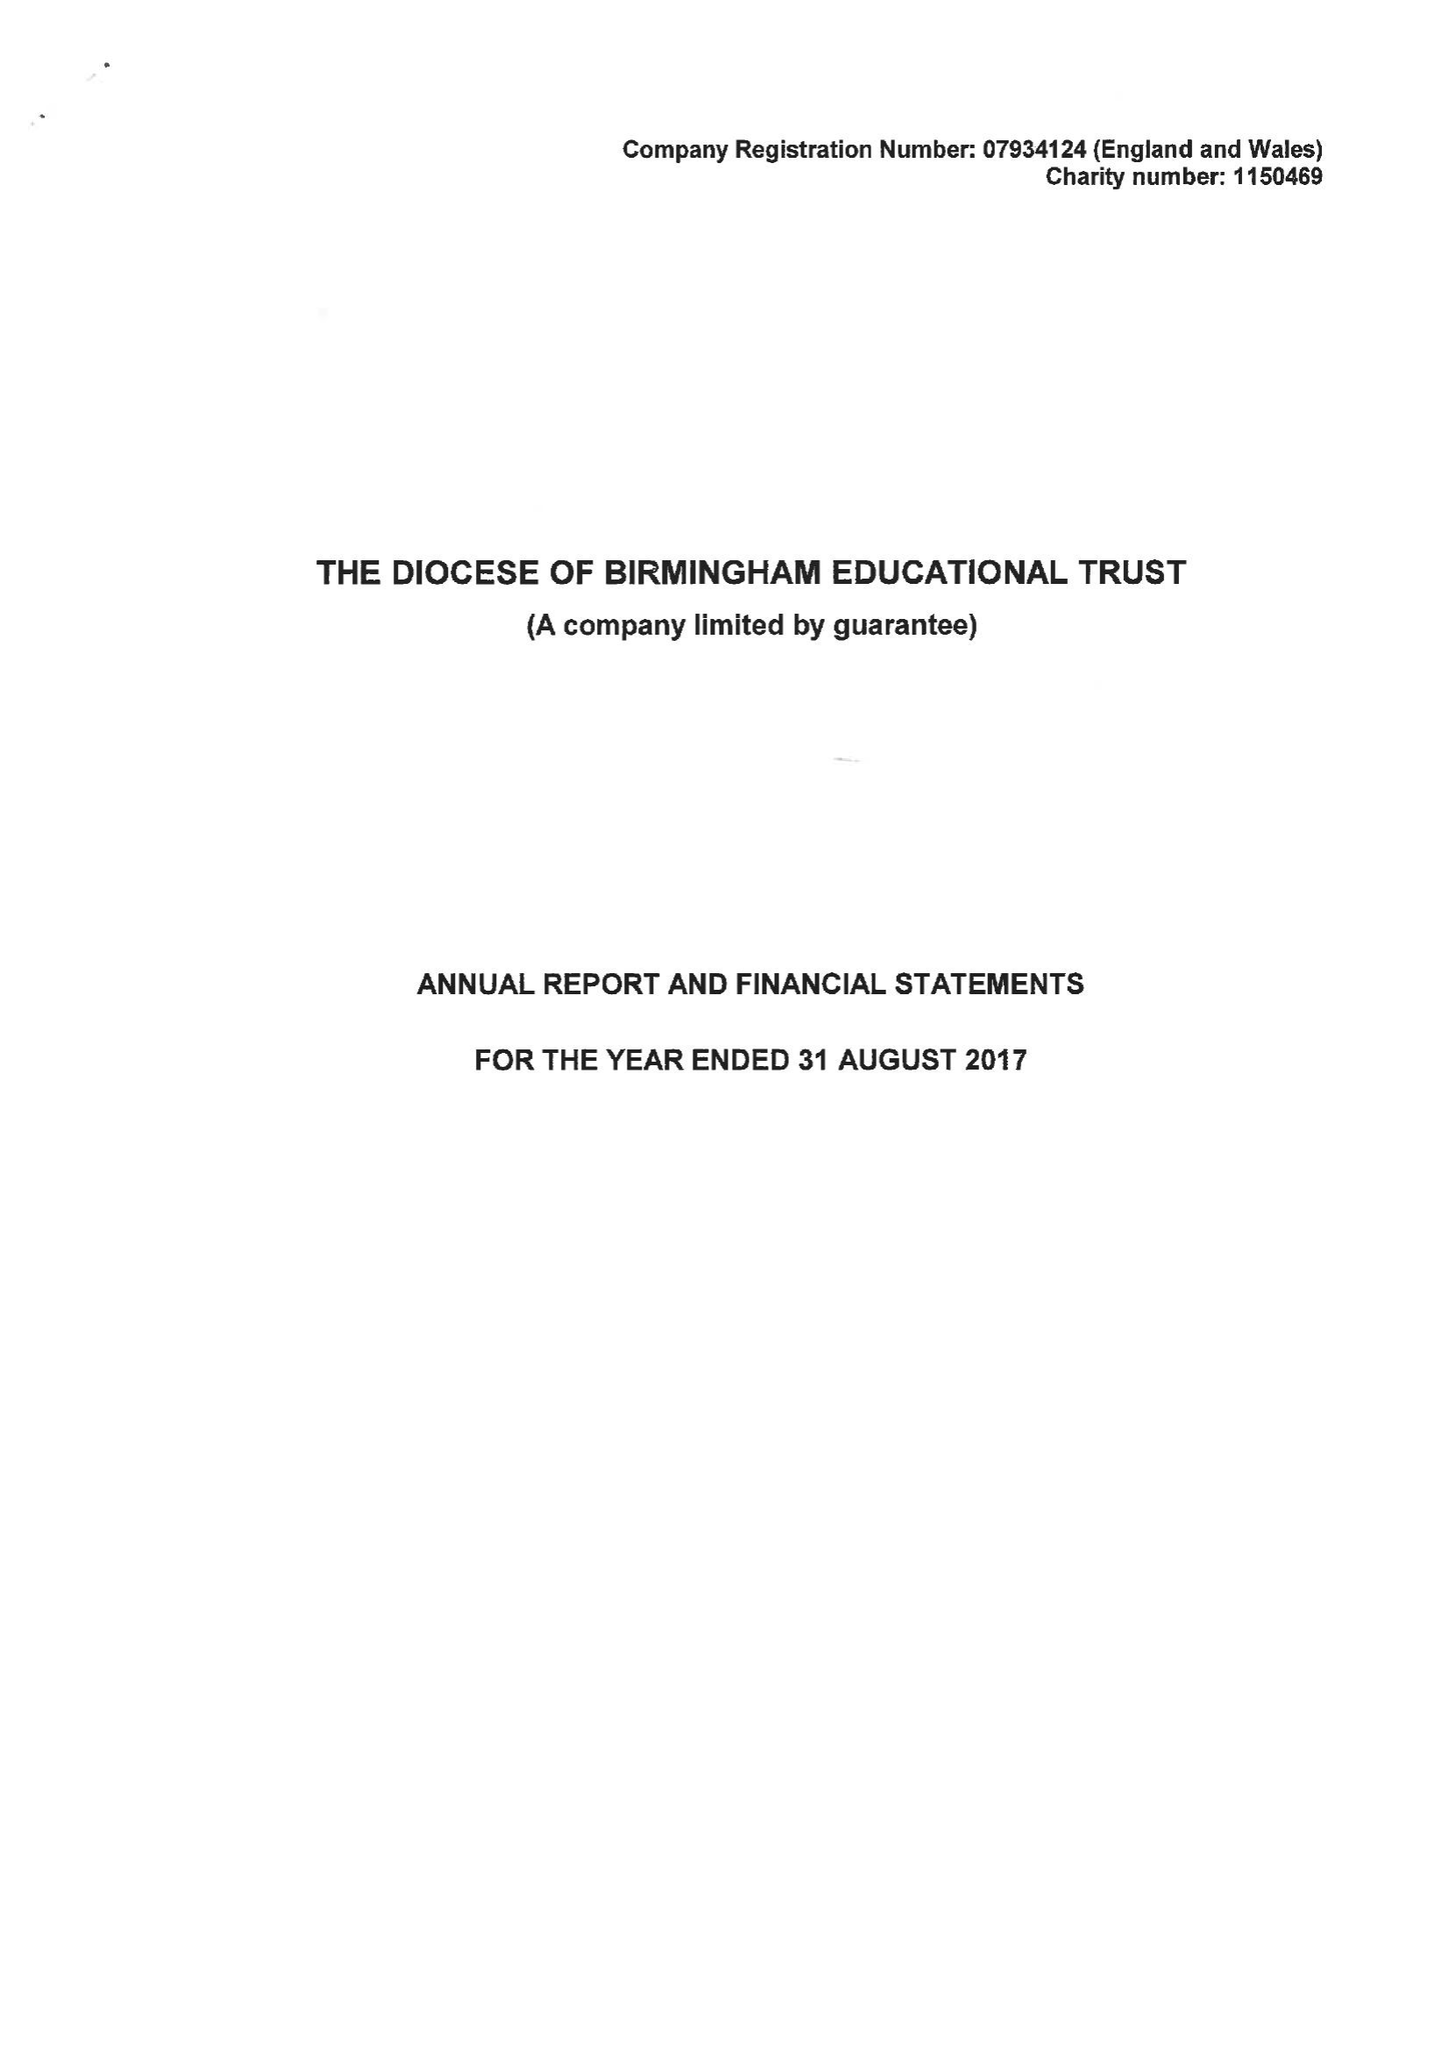What is the value for the income_annually_in_british_pounds?
Answer the question using a single word or phrase. 180390.00 